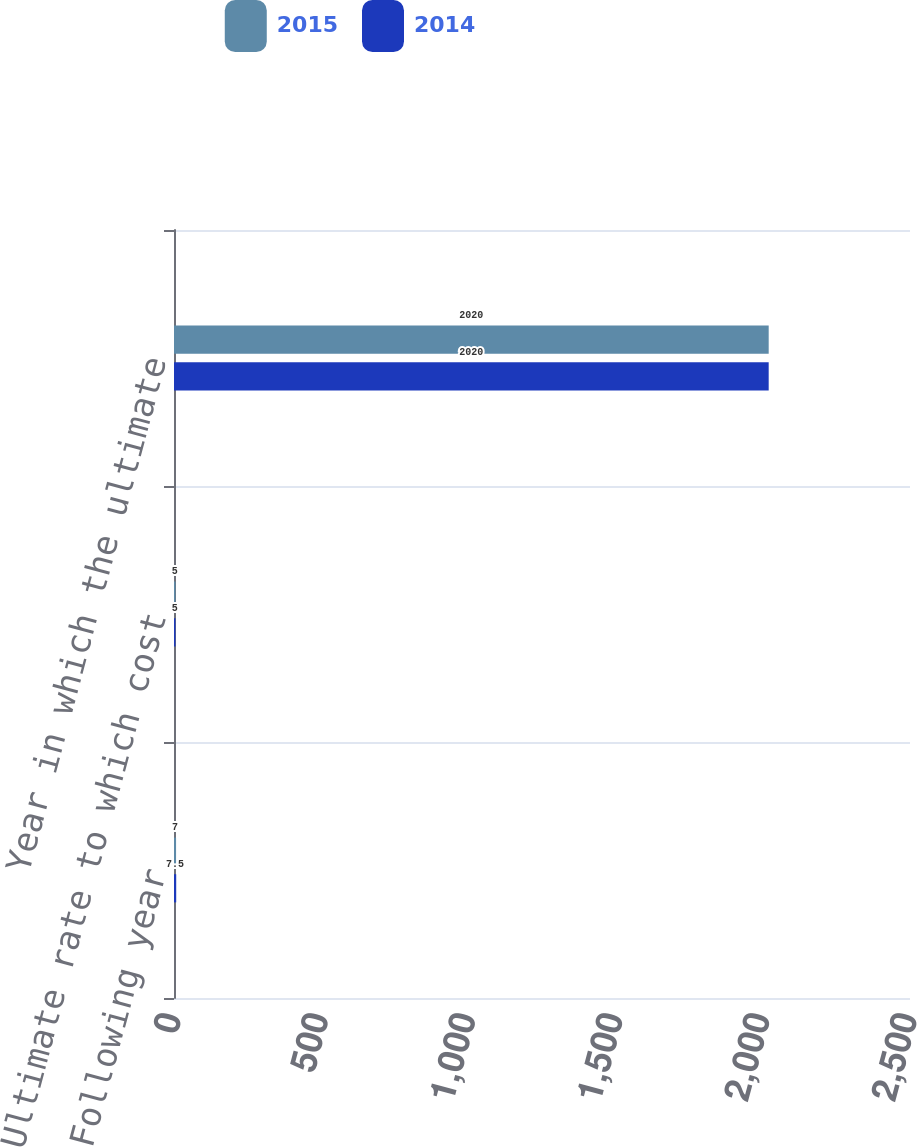Convert chart. <chart><loc_0><loc_0><loc_500><loc_500><stacked_bar_chart><ecel><fcel>Following year<fcel>Ultimate rate to which cost<fcel>Year in which the ultimate<nl><fcel>2015<fcel>7<fcel>5<fcel>2020<nl><fcel>2014<fcel>7.5<fcel>5<fcel>2020<nl></chart> 